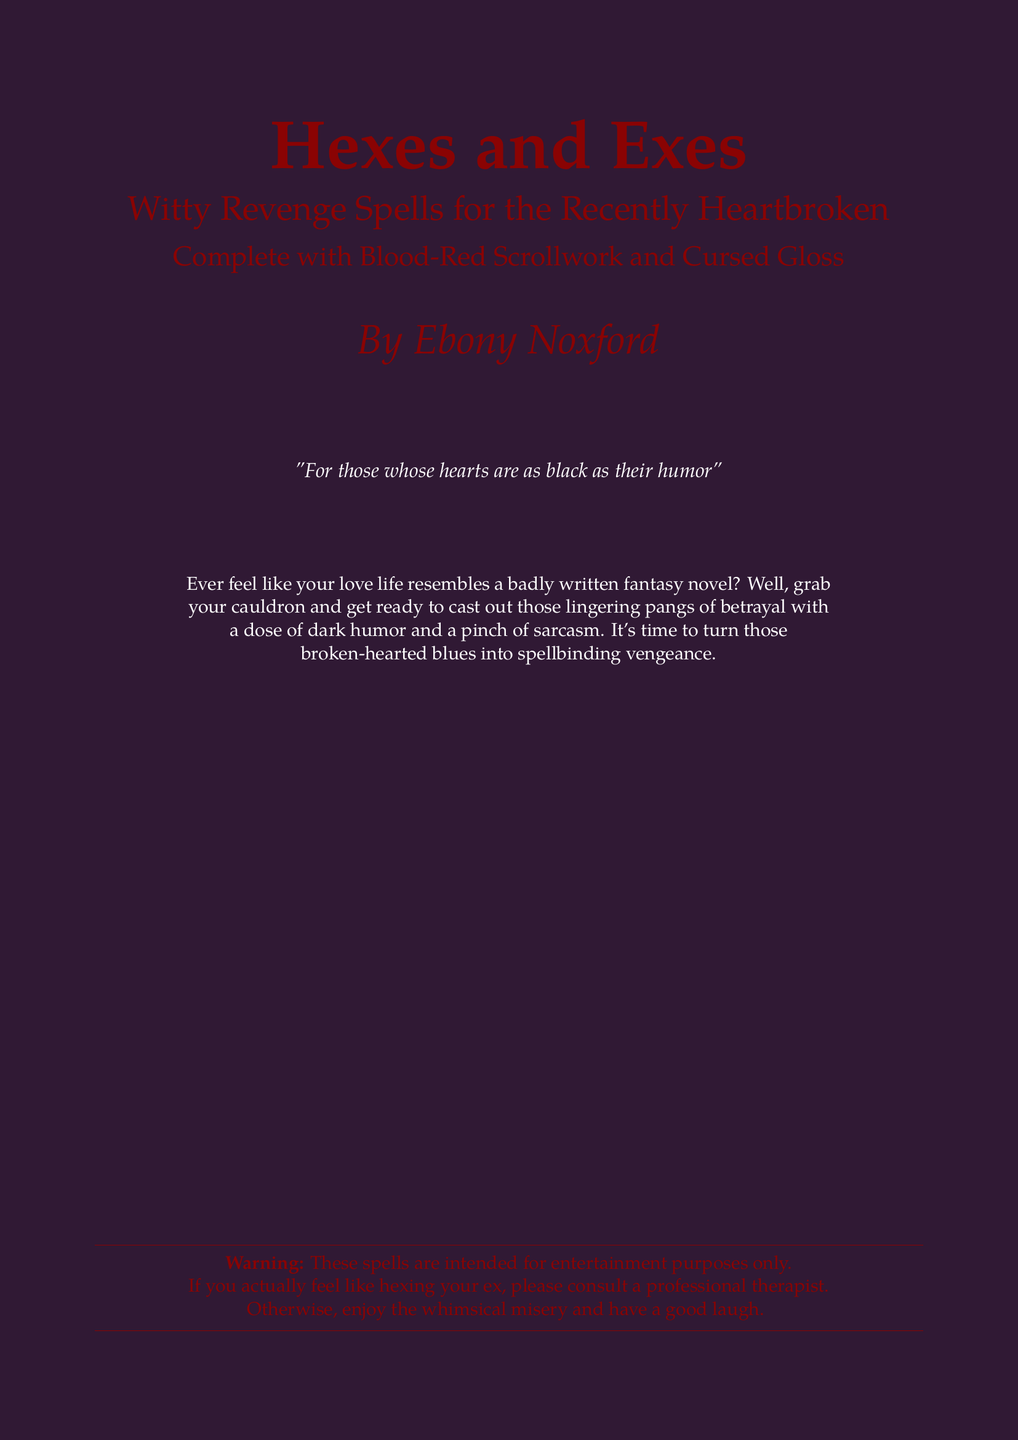What is the title of the book? The title appears prominently at the top of the cover in large font.
Answer: Hexes and Exes Who is the author of the book? The author is credited near the bottom of the cover.
Answer: Ebony Noxford What is the subtitle of the book? The subtitle provides additional context and is displayed below the title.
Answer: Witty Revenge Spells for the Recently Heartbroken What color is the scrollwork mentioned on the cover? The scrollwork's color is specified in the subtitle.
Answer: Blood-Red What is the primary background color of the document? The background color is stated at the beginning of the document.
Answer: Dark Purple What does the warning note advise against? The warning note addresses what to do if someone feels like hexing their ex.
Answer: Hexing your ex How does the author describe the hearts of the audience? The author's description appears as a quote on the cover.
Answer: As black as their humor What thematic tone does the book promote? The document conveys a specific emotional response related to heartbreak.
Answer: Dark humor What should readers prepare for according to the book's description? The description outlines an activity related to dealing with feelings.
Answer: Casting out those lingering pangs of betrayal 